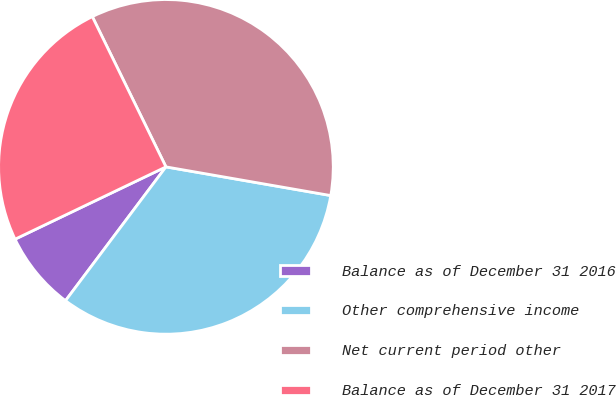Convert chart to OTSL. <chart><loc_0><loc_0><loc_500><loc_500><pie_chart><fcel>Balance as of December 31 2016<fcel>Other comprehensive income<fcel>Net current period other<fcel>Balance as of December 31 2017<nl><fcel>7.64%<fcel>32.5%<fcel>34.99%<fcel>24.86%<nl></chart> 